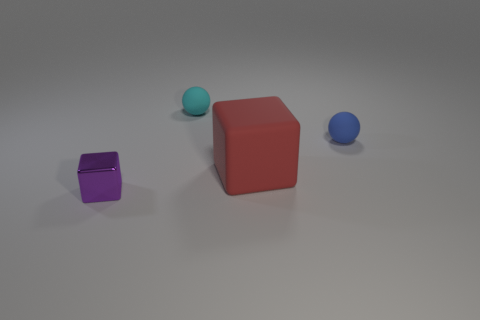Are there any other things that are the same size as the rubber cube?
Offer a very short reply. No. There is another object that is the same shape as the big red matte thing; what is its material?
Keep it short and to the point. Metal. How many things are either things to the left of the red rubber thing or tiny cyan rubber things behind the blue rubber thing?
Provide a short and direct response. 2. What shape is the other large object that is made of the same material as the blue object?
Provide a short and direct response. Cube. What number of things are there?
Your answer should be compact. 4. How many things are either matte balls that are in front of the small cyan rubber object or big red cubes?
Provide a short and direct response. 2. How many small objects are either red blocks or blue rubber balls?
Your answer should be compact. 1. Is the number of blue matte things greater than the number of large cyan cylinders?
Your answer should be compact. Yes. Is the material of the big object the same as the tiny purple block?
Give a very brief answer. No. Is there any other thing that is made of the same material as the tiny purple thing?
Provide a succinct answer. No. 